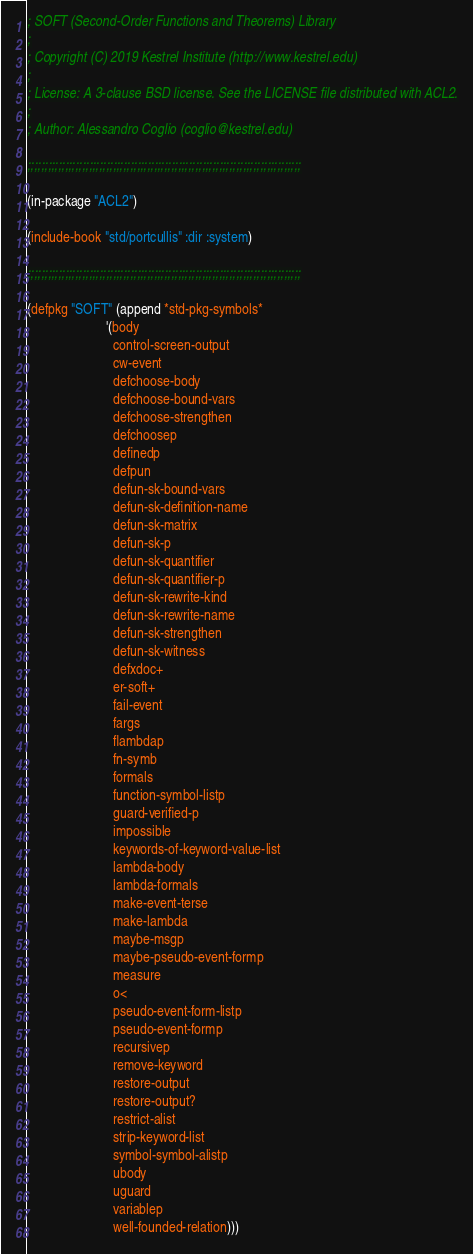Convert code to text. <code><loc_0><loc_0><loc_500><loc_500><_Lisp_>; SOFT (Second-Order Functions and Theorems) Library
;
; Copyright (C) 2019 Kestrel Institute (http://www.kestrel.edu)
;
; License: A 3-clause BSD license. See the LICENSE file distributed with ACL2.
;
; Author: Alessandro Coglio (coglio@kestrel.edu)

;;;;;;;;;;;;;;;;;;;;;;;;;;;;;;;;;;;;;;;;;;;;;;;;;;;;;;;;;;;;;;;;;;;;;;;;;;;;;;;;

(in-package "ACL2")

(include-book "std/portcullis" :dir :system)

;;;;;;;;;;;;;;;;;;;;;;;;;;;;;;;;;;;;;;;;;;;;;;;;;;;;;;;;;;;;;;;;;;;;;;;;;;;;;;;;

(defpkg "SOFT" (append *std-pkg-symbols*
                       '(body
                         control-screen-output
                         cw-event
                         defchoose-body
                         defchoose-bound-vars
                         defchoose-strengthen
                         defchoosep
                         definedp
                         defpun
                         defun-sk-bound-vars
                         defun-sk-definition-name
                         defun-sk-matrix
                         defun-sk-p
                         defun-sk-quantifier
                         defun-sk-quantifier-p
                         defun-sk-rewrite-kind
                         defun-sk-rewrite-name
                         defun-sk-strengthen
                         defun-sk-witness
                         defxdoc+
                         er-soft+
                         fail-event
                         fargs
                         flambdap
                         fn-symb
                         formals
                         function-symbol-listp
                         guard-verified-p
                         impossible
                         keywords-of-keyword-value-list
                         lambda-body
                         lambda-formals
                         make-event-terse
                         make-lambda
                         maybe-msgp
                         maybe-pseudo-event-formp
                         measure
                         o<
                         pseudo-event-form-listp
                         pseudo-event-formp
                         recursivep
                         remove-keyword
                         restore-output
                         restore-output?
                         restrict-alist
                         strip-keyword-list
                         symbol-symbol-alistp
                         ubody
                         uguard
                         variablep
                         well-founded-relation)))
</code> 